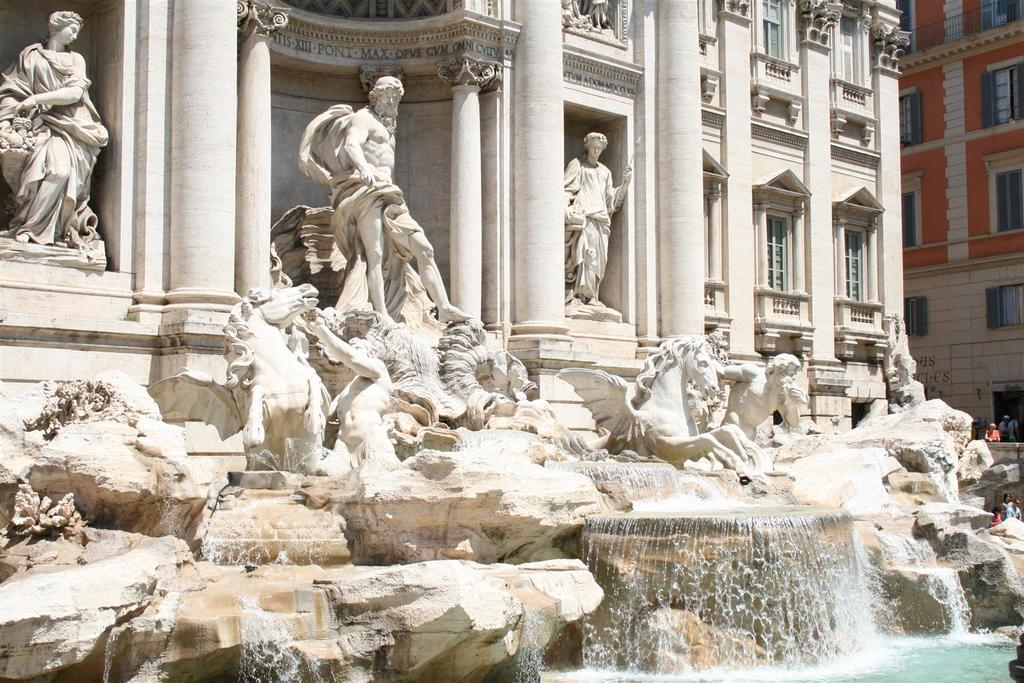What type of objects can be seen in the image? There are statues in the image. What is another feature present in the image? There is a water fountain in the image. What type of structures are visible in the image? There are buildings in the image. Are there any people in the image? Yes, there are persons in the image. What type of operation is being performed by the persons in the image? There is no operation being performed by the persons in the image; they are simply present in the scene. Can you tell me who the partner of the statue is in the image? There is no partner mentioned or depicted with the statue in the image. 